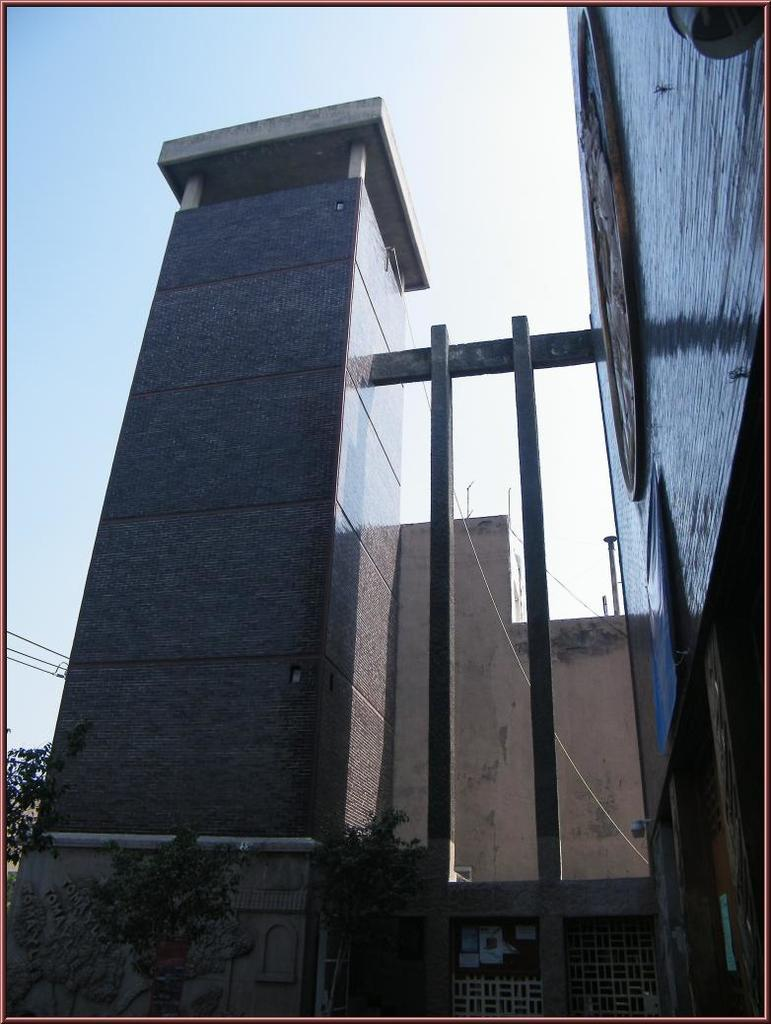What type of structure is present in the image? There is a building in the image. What else can be seen in the image besides the building? There are plants and windows visible in the image. What is visible in the background of the image? The sky is visible in the background of the image. What type of bone can be seen sticking out of the building in the image? There is no bone present in the image; it features a building, plants, windows, and the sky. 